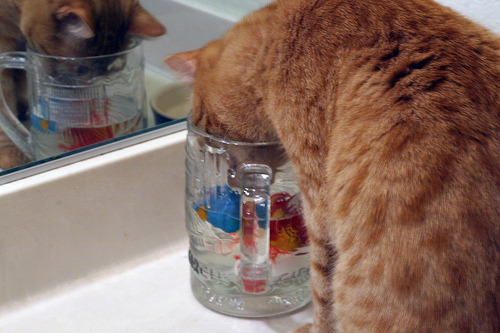<image>
Can you confirm if the water is in front of the cat? Yes. The water is positioned in front of the cat, appearing closer to the camera viewpoint. 